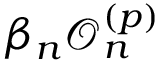Convert formula to latex. <formula><loc_0><loc_0><loc_500><loc_500>\beta _ { n } \mathcal { O } _ { n } ^ { ( { p } ) }</formula> 